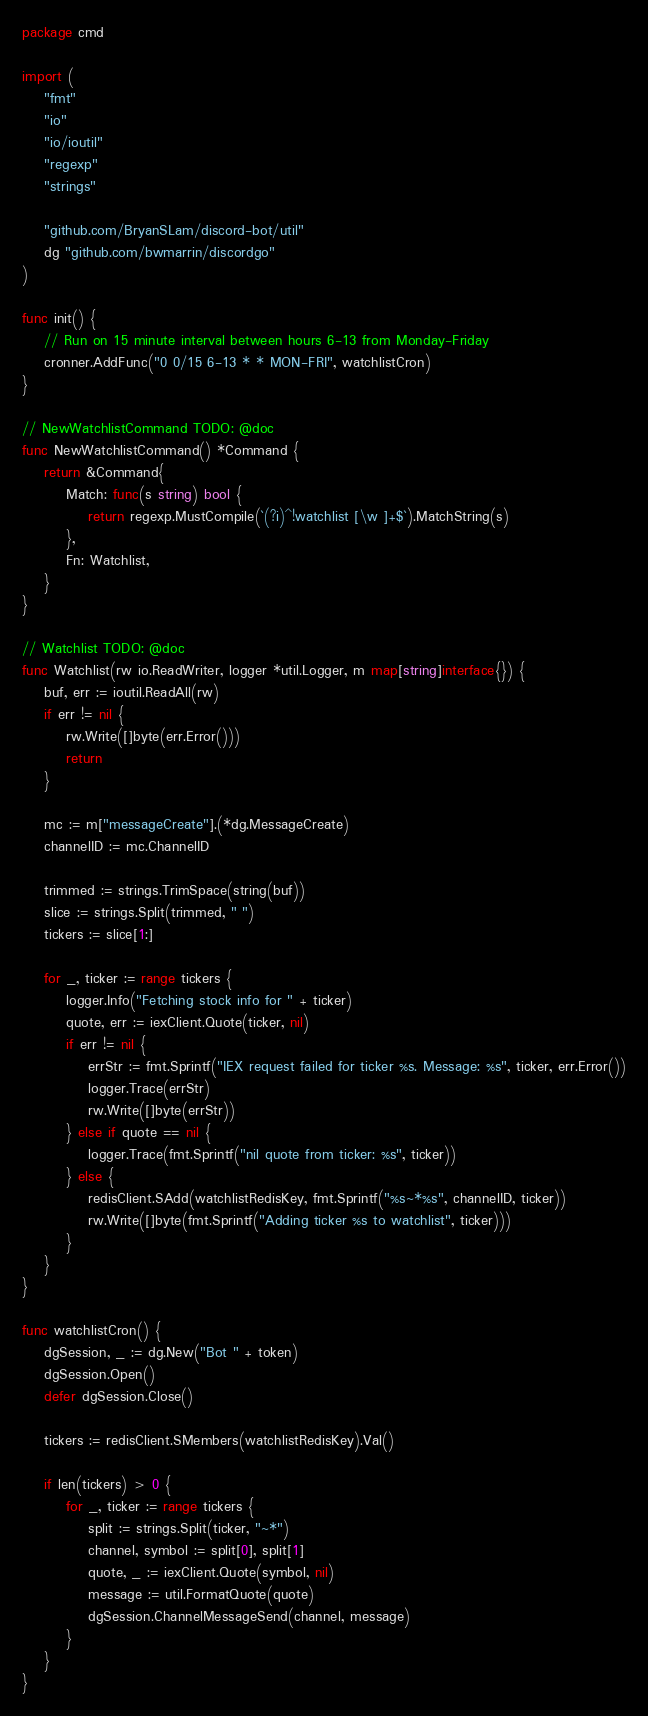<code> <loc_0><loc_0><loc_500><loc_500><_Go_>package cmd

import (
	"fmt"
	"io"
	"io/ioutil"
	"regexp"
	"strings"

	"github.com/BryanSLam/discord-bot/util"
	dg "github.com/bwmarrin/discordgo"
)

func init() {
	// Run on 15 minute interval between hours 6-13 from Monday-Friday
	cronner.AddFunc("0 0/15 6-13 * * MON-FRI", watchlistCron)
}

// NewWatchlistCommand TODO: @doc
func NewWatchlistCommand() *Command {
	return &Command{
		Match: func(s string) bool {
			return regexp.MustCompile(`(?i)^!watchlist [\w ]+$`).MatchString(s)
		},
		Fn: Watchlist,
	}
}

// Watchlist TODO: @doc
func Watchlist(rw io.ReadWriter, logger *util.Logger, m map[string]interface{}) {
	buf, err := ioutil.ReadAll(rw)
	if err != nil {
		rw.Write([]byte(err.Error()))
		return
	}

	mc := m["messageCreate"].(*dg.MessageCreate)
	channelID := mc.ChannelID

	trimmed := strings.TrimSpace(string(buf))
	slice := strings.Split(trimmed, " ")
	tickers := slice[1:]

	for _, ticker := range tickers {
		logger.Info("Fetching stock info for " + ticker)
		quote, err := iexClient.Quote(ticker, nil)
		if err != nil {
			errStr := fmt.Sprintf("IEX request failed for ticker %s. Message: %s", ticker, err.Error())
			logger.Trace(errStr)
			rw.Write([]byte(errStr))
		} else if quote == nil {
			logger.Trace(fmt.Sprintf("nil quote from ticker: %s", ticker))
		} else {
			redisClient.SAdd(watchlistRedisKey, fmt.Sprintf("%s~*%s", channelID, ticker))
			rw.Write([]byte(fmt.Sprintf("Adding ticker %s to watchlist", ticker)))
		}
	}
}

func watchlistCron() {
	dgSession, _ := dg.New("Bot " + token)
	dgSession.Open()
	defer dgSession.Close()

	tickers := redisClient.SMembers(watchlistRedisKey).Val()

	if len(tickers) > 0 {
		for _, ticker := range tickers {
			split := strings.Split(ticker, "~*")
			channel, symbol := split[0], split[1]
			quote, _ := iexClient.Quote(symbol, nil)
			message := util.FormatQuote(quote)
			dgSession.ChannelMessageSend(channel, message)
		}
	}
}
</code> 